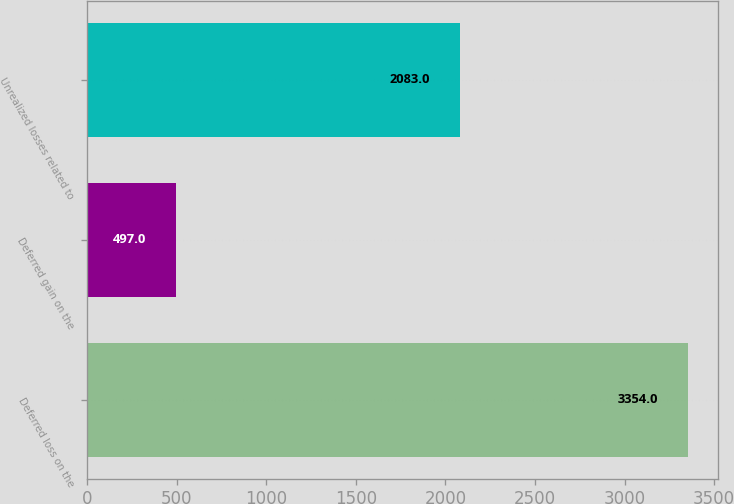<chart> <loc_0><loc_0><loc_500><loc_500><bar_chart><fcel>Deferred loss on the<fcel>Deferred gain on the<fcel>Unrealized losses related to<nl><fcel>3354<fcel>497<fcel>2083<nl></chart> 